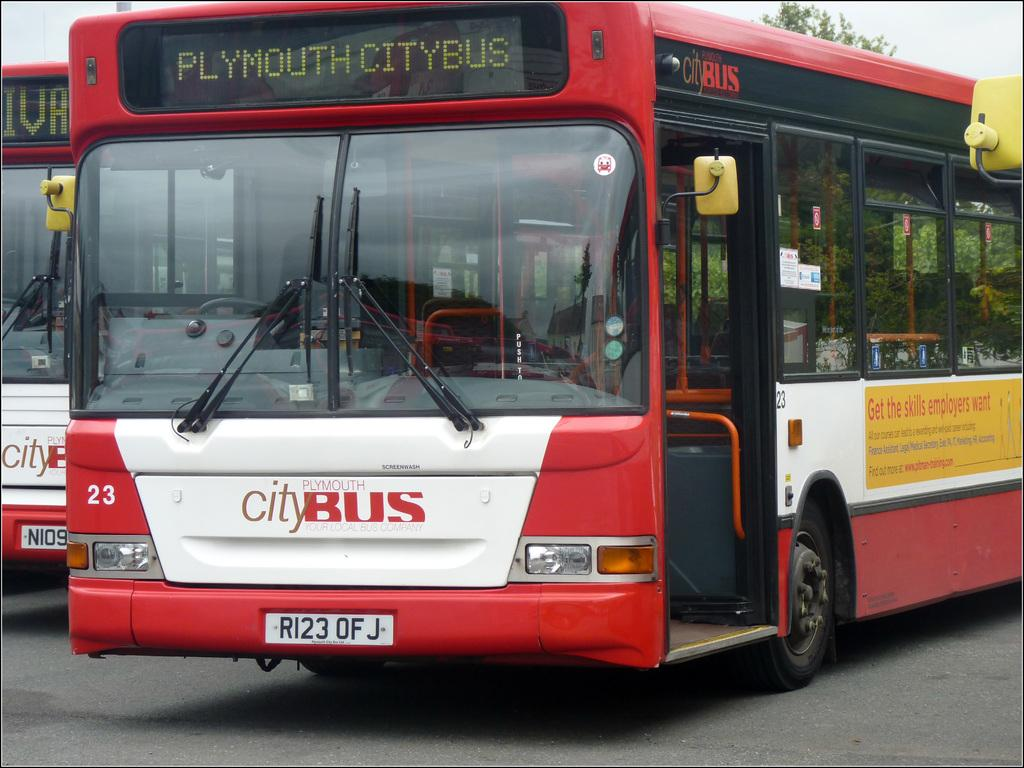How many buses are in the image? There are two buses in the image. What color combination do the buses have? The buses are in a red and white color combination. Where are the buses located in the image? The buses are on the road. What can be seen in the background of the image? There is a tree and the sky visible in the background of the image. What type of quartz can be seen in the shop in the image? There is no quartz or shop present in the image; it features two buses on the road. 